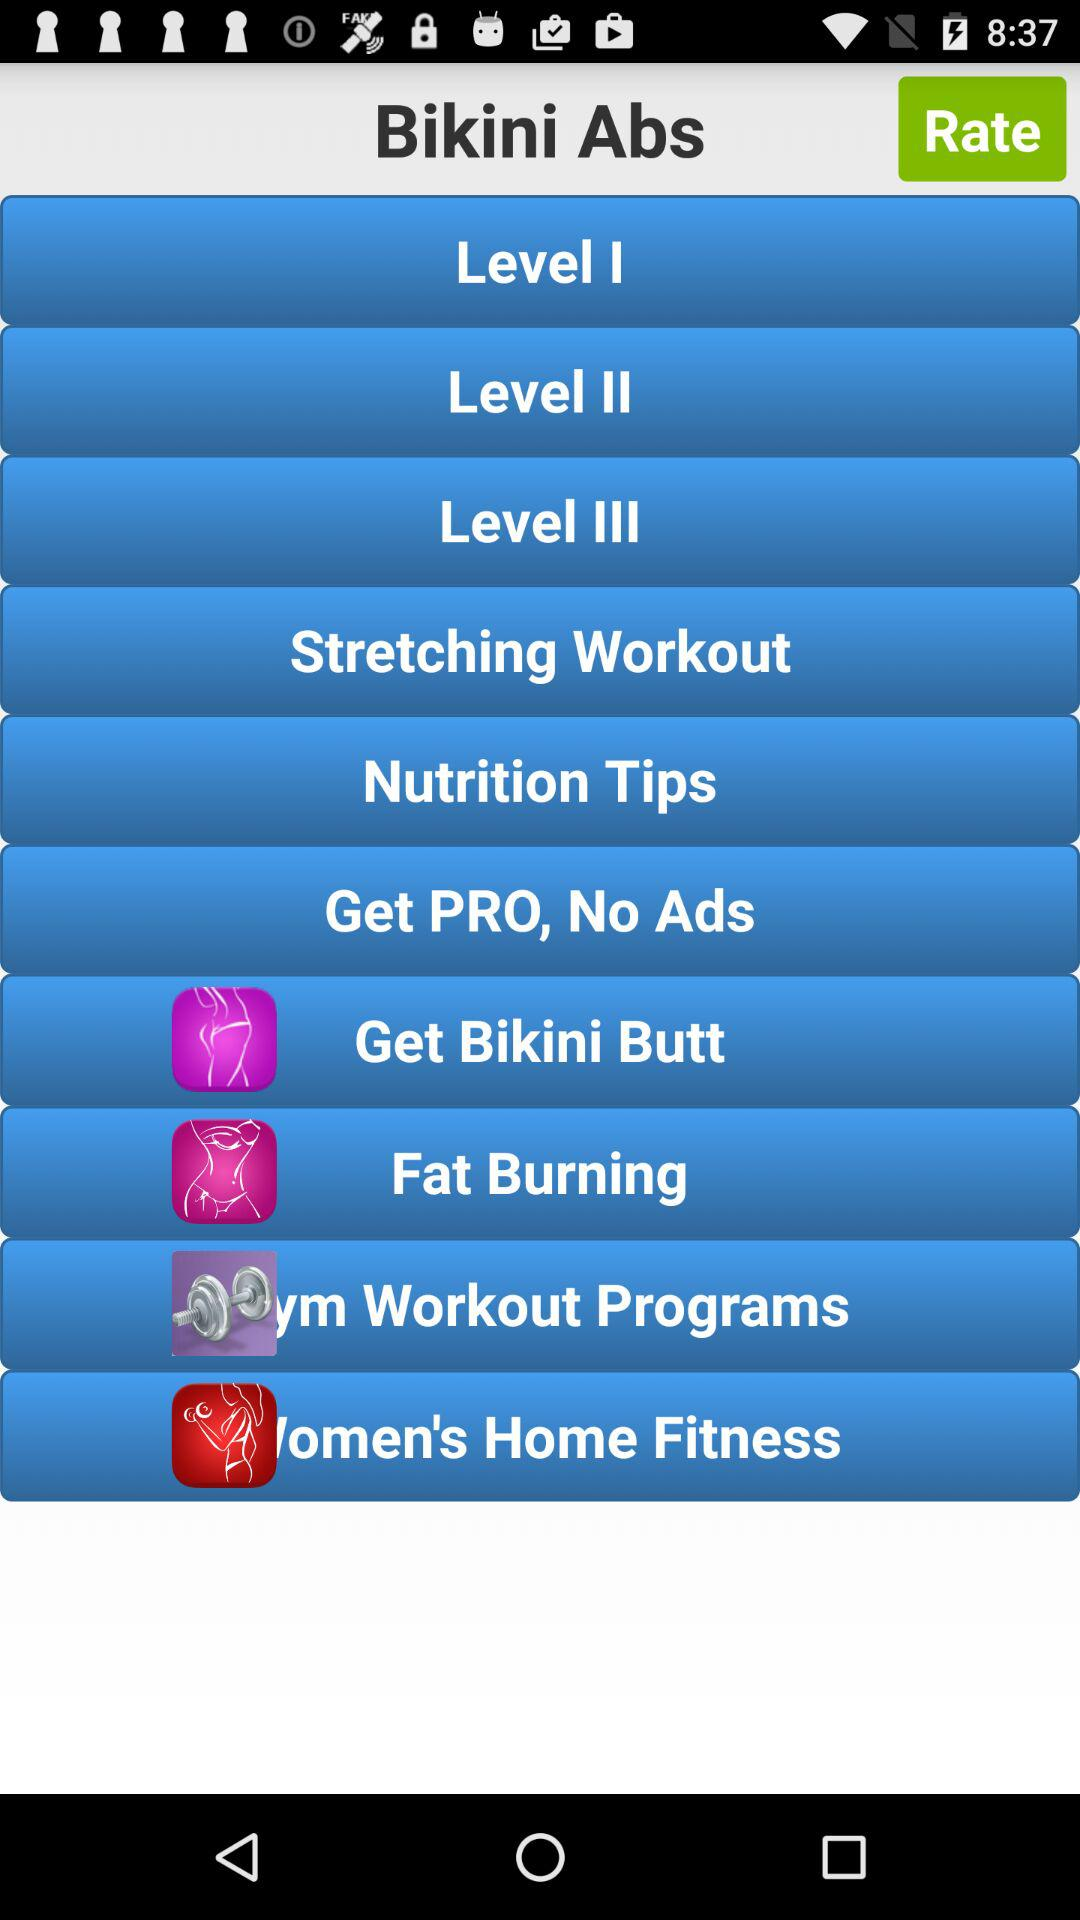What is the name of the application? The application name is Bikini Abs. 